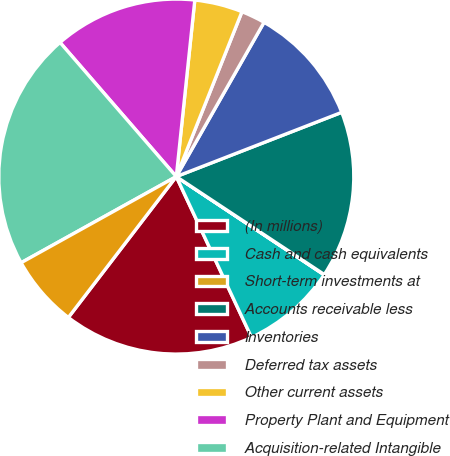Convert chart. <chart><loc_0><loc_0><loc_500><loc_500><pie_chart><fcel>(In millions)<fcel>Cash and cash equivalents<fcel>Short-term investments at<fcel>Accounts receivable less<fcel>Inventories<fcel>Deferred tax assets<fcel>Other current assets<fcel>Property Plant and Equipment<fcel>Acquisition-related Intangible<fcel>Other Assets<nl><fcel>17.37%<fcel>8.7%<fcel>0.03%<fcel>15.2%<fcel>10.87%<fcel>2.2%<fcel>4.37%<fcel>13.03%<fcel>21.7%<fcel>6.53%<nl></chart> 